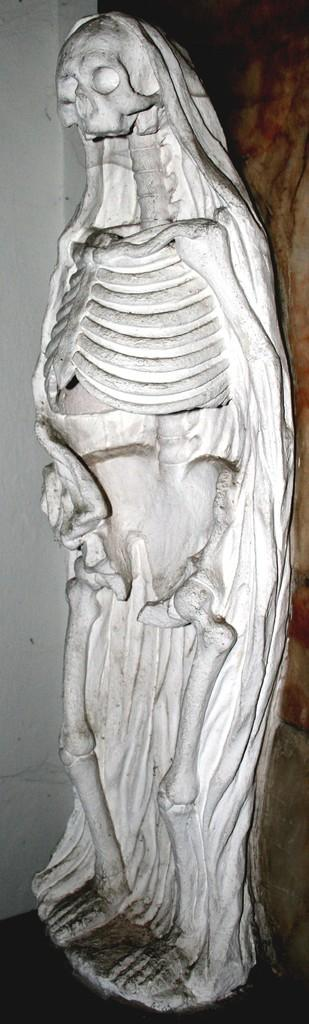What is the main subject of the image? There is a statue of a skeleton in the image. What can be seen in the background of the image? There is a wall in the image. What type of string is wrapped around the skeleton's neck in the image? There is no string present around the skeleton's neck in the image. What kind of cake is being served at the event in the image? There is no event or cake present in the image; it only features a statue of a skeleton and a wall. 